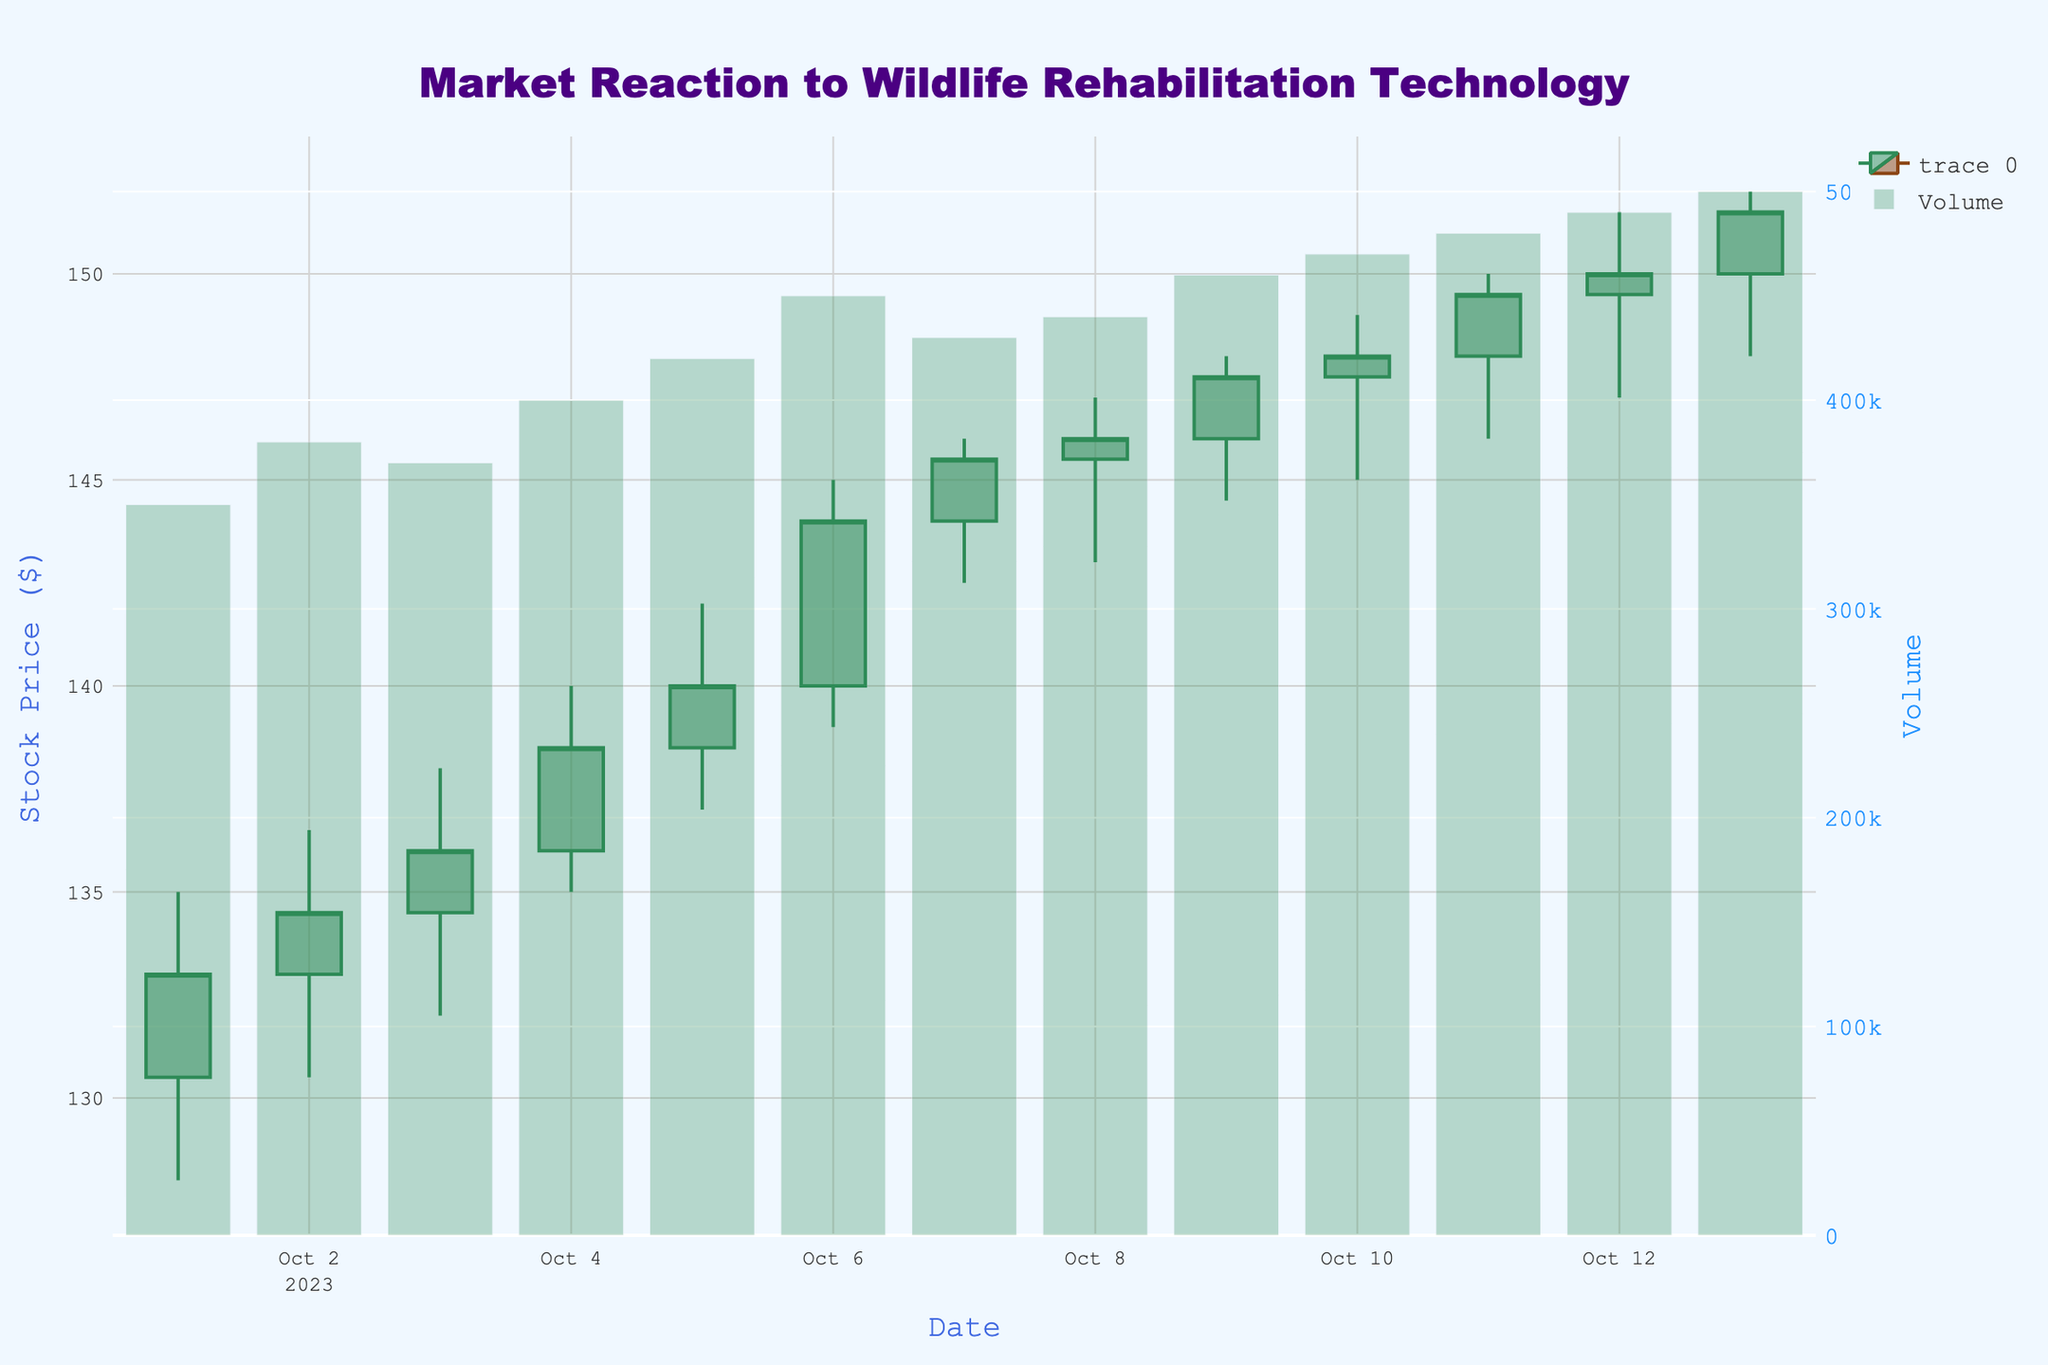What's the title of the chart? The title of the chart is prominently displayed at the top center of the figure.
Answer: Market Reaction to Wildlife Rehabilitation Technology What is the color of the increasing and decreasing candlesticks? The increasing candlesticks are represented in sea green, and the decreasing ones are shown in saddle brown.
Answer: Sea green and Saddle brown On which date did the highest closing price occur? By examining the highest closing price in the chart, we can see that it occurs on October 13th.
Answer: October 13th What was the opening price on October 2nd? The opening price can be found at the position where the candlestick begins for October 2nd.
Answer: 133.00 What was the volume on October 6th, and was the candlestick on that day increasing or decreasing? The volume bar for October 6th shows a volume of 450,000, and the candlestick is green, indicating an increase.
Answer: 450,000, increasing Which date had the lowest price, and what was that price? Check the lowest points of the candlesticks to find the date with the lowest price, which is October 1st with a price of 128.00.
Answer: October 1st, 128.00 Which day showed the most significant increase in closing price compared to the previous day? By comparing the closing prices day by day, October 6th saw a closing increase from 140.00 to 144.00, marking the most significant gain.
Answer: October 6th What is the range of stock prices between October 1st and October 13th? The range is calculated by finding the highest high (152.00) and the lowest low (128.00) within the dates and subtracting the low from the high. 152.00 - 128.00 = 24.00
Answer: 24.00 Between October 4th and October 5th, what was the change in closing stock price? The closing stock price on October 4th was 138.50, and on October 5th it was 140.00. The difference is 140.00 - 138.50 = 1.50.
Answer: 1.50 When did the stock price first close above 145.00? Scan the closing prices until you find a value above 145.00, which first appears on October 7th.
Answer: October 7th 